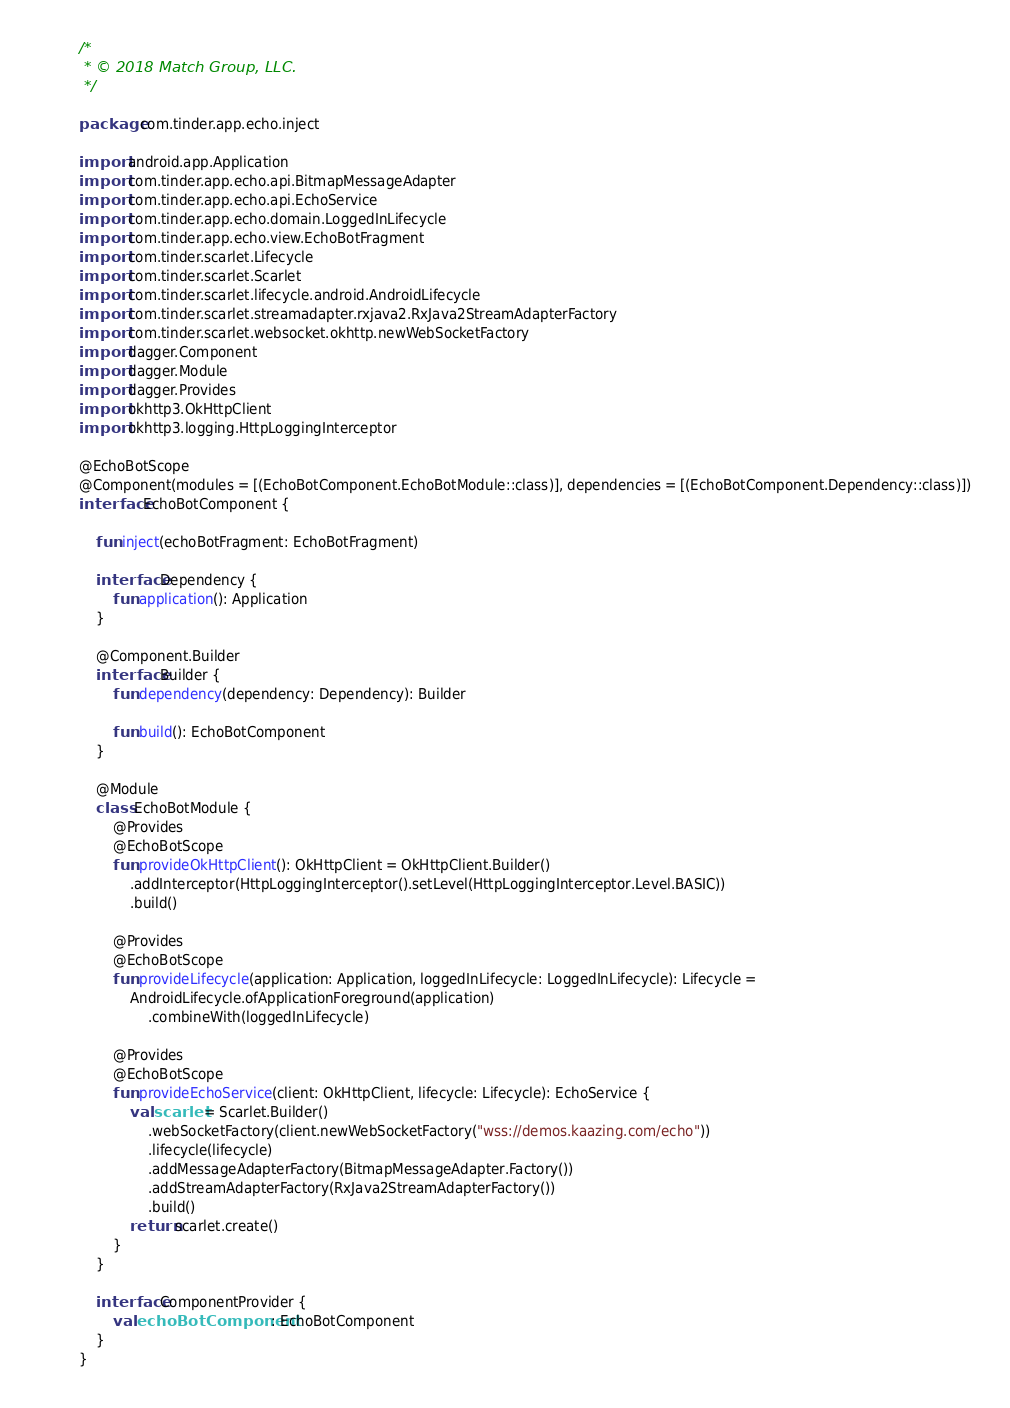Convert code to text. <code><loc_0><loc_0><loc_500><loc_500><_Kotlin_>/*
 * © 2018 Match Group, LLC.
 */

package com.tinder.app.echo.inject

import android.app.Application
import com.tinder.app.echo.api.BitmapMessageAdapter
import com.tinder.app.echo.api.EchoService
import com.tinder.app.echo.domain.LoggedInLifecycle
import com.tinder.app.echo.view.EchoBotFragment
import com.tinder.scarlet.Lifecycle
import com.tinder.scarlet.Scarlet
import com.tinder.scarlet.lifecycle.android.AndroidLifecycle
import com.tinder.scarlet.streamadapter.rxjava2.RxJava2StreamAdapterFactory
import com.tinder.scarlet.websocket.okhttp.newWebSocketFactory
import dagger.Component
import dagger.Module
import dagger.Provides
import okhttp3.OkHttpClient
import okhttp3.logging.HttpLoggingInterceptor

@EchoBotScope
@Component(modules = [(EchoBotComponent.EchoBotModule::class)], dependencies = [(EchoBotComponent.Dependency::class)])
interface EchoBotComponent {

    fun inject(echoBotFragment: EchoBotFragment)

    interface Dependency {
        fun application(): Application
    }

    @Component.Builder
    interface Builder {
        fun dependency(dependency: Dependency): Builder

        fun build(): EchoBotComponent
    }

    @Module
    class EchoBotModule {
        @Provides
        @EchoBotScope
        fun provideOkHttpClient(): OkHttpClient = OkHttpClient.Builder()
            .addInterceptor(HttpLoggingInterceptor().setLevel(HttpLoggingInterceptor.Level.BASIC))
            .build()

        @Provides
        @EchoBotScope
        fun provideLifecycle(application: Application, loggedInLifecycle: LoggedInLifecycle): Lifecycle =
            AndroidLifecycle.ofApplicationForeground(application)
                .combineWith(loggedInLifecycle)

        @Provides
        @EchoBotScope
        fun provideEchoService(client: OkHttpClient, lifecycle: Lifecycle): EchoService {
            val scarlet = Scarlet.Builder()
                .webSocketFactory(client.newWebSocketFactory("wss://demos.kaazing.com/echo"))
                .lifecycle(lifecycle)
                .addMessageAdapterFactory(BitmapMessageAdapter.Factory())
                .addStreamAdapterFactory(RxJava2StreamAdapterFactory())
                .build()
            return scarlet.create()
        }
    }

    interface ComponentProvider {
        val echoBotComponent: EchoBotComponent
    }
}
</code> 